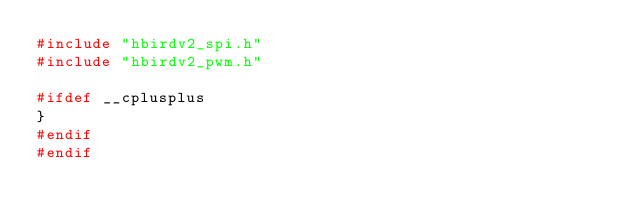<code> <loc_0><loc_0><loc_500><loc_500><_C_>#include "hbirdv2_spi.h"
#include "hbirdv2_pwm.h"

#ifdef __cplusplus
}
#endif
#endif
</code> 